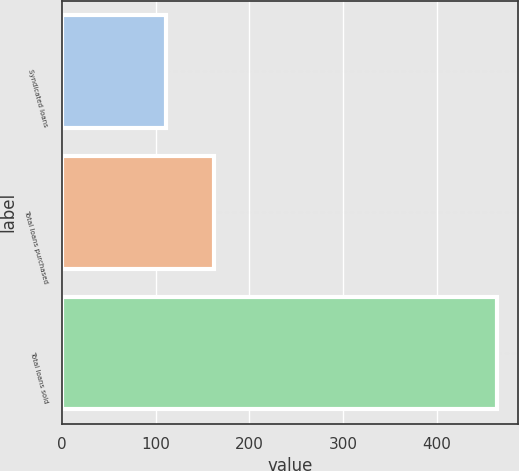Convert chart. <chart><loc_0><loc_0><loc_500><loc_500><bar_chart><fcel>Syndicated loans<fcel>Total loans purchased<fcel>Total loans sold<nl><fcel>111<fcel>162<fcel>464<nl></chart> 